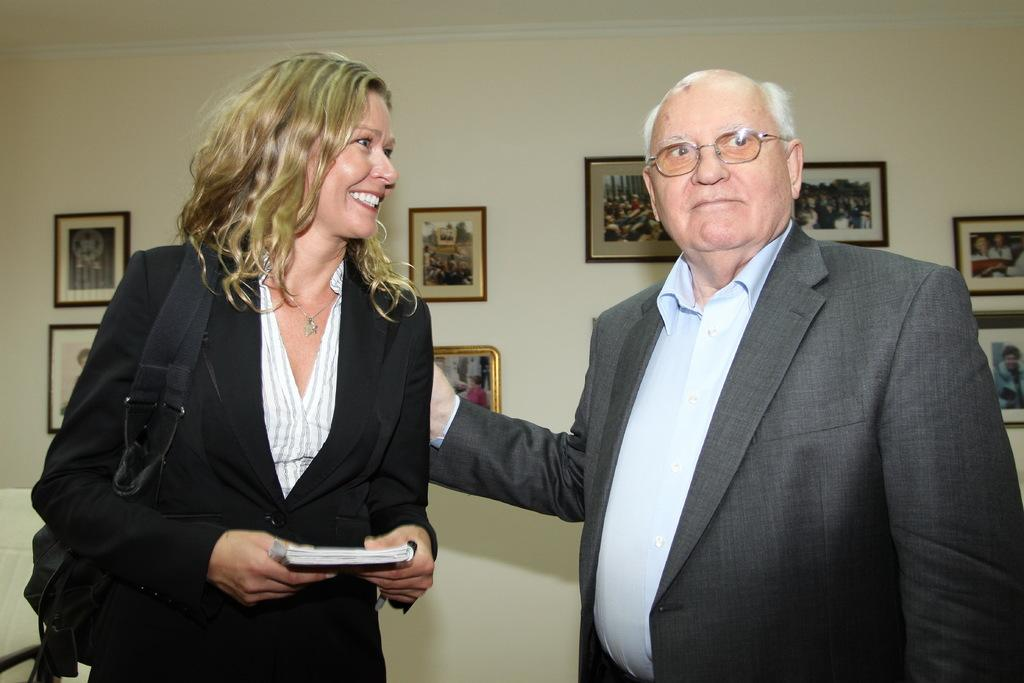How many people are present in the image? There are two persons standing in the image. What is one of the persons holding? There is a person holding a book in the image. Can you describe any furniture in the image? There is a chair in the image. What can be seen on the wall in the background of the image? There are frames attached to the wall in the background of the image. Can you tell me if the robin is flying in the image? There is no robin present in the image. What type of recess is visible in the image? There is no recess present in the image. 